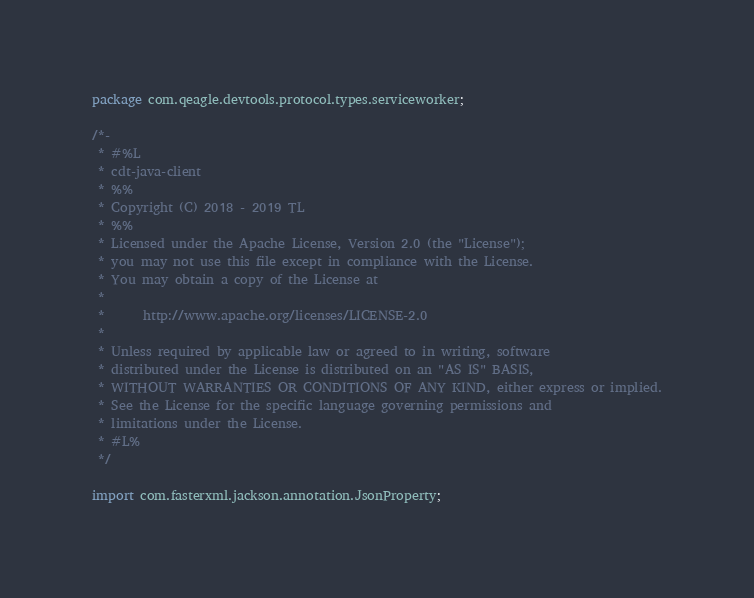Convert code to text. <code><loc_0><loc_0><loc_500><loc_500><_Java_>package com.qeagle.devtools.protocol.types.serviceworker;

/*-
 * #%L
 * cdt-java-client
 * %%
 * Copyright (C) 2018 - 2019 TL
 * %%
 * Licensed under the Apache License, Version 2.0 (the "License");
 * you may not use this file except in compliance with the License.
 * You may obtain a copy of the License at
 *
 *      http://www.apache.org/licenses/LICENSE-2.0
 *
 * Unless required by applicable law or agreed to in writing, software
 * distributed under the License is distributed on an "AS IS" BASIS,
 * WITHOUT WARRANTIES OR CONDITIONS OF ANY KIND, either express or implied.
 * See the License for the specific language governing permissions and
 * limitations under the License.
 * #L%
 */

import com.fasterxml.jackson.annotation.JsonProperty;
</code> 